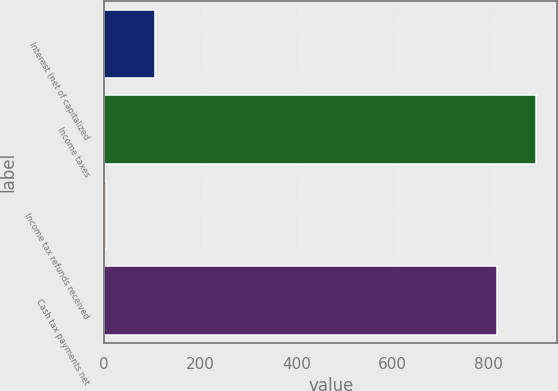Convert chart. <chart><loc_0><loc_0><loc_500><loc_500><bar_chart><fcel>Interest (net of capitalized<fcel>Income taxes<fcel>Income tax refunds received<fcel>Cash tax payments net<nl><fcel>105<fcel>897.6<fcel>5<fcel>816<nl></chart> 